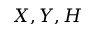Convert formula to latex. <formula><loc_0><loc_0><loc_500><loc_500>X , Y , H</formula> 